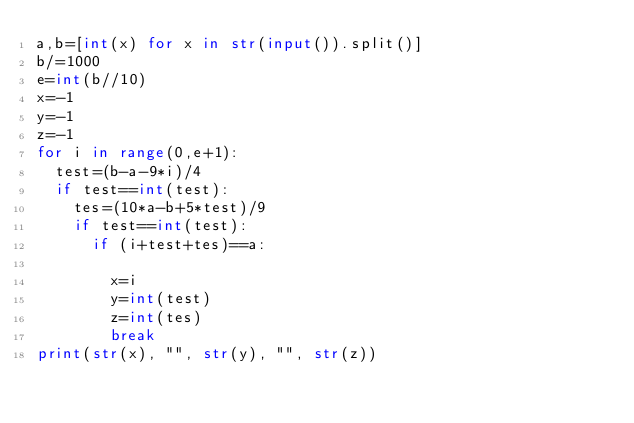Convert code to text. <code><loc_0><loc_0><loc_500><loc_500><_Python_>a,b=[int(x) for x in str(input()).split()]
b/=1000
e=int(b//10)
x=-1
y=-1
z=-1
for i in range(0,e+1):
  test=(b-a-9*i)/4
  if test==int(test):
    tes=(10*a-b+5*test)/9
    if test==int(test):
      if (i+test+tes)==a:
          
        x=i
        y=int(test)
        z=int(tes)
        break
print(str(x), "", str(y), "", str(z))


</code> 